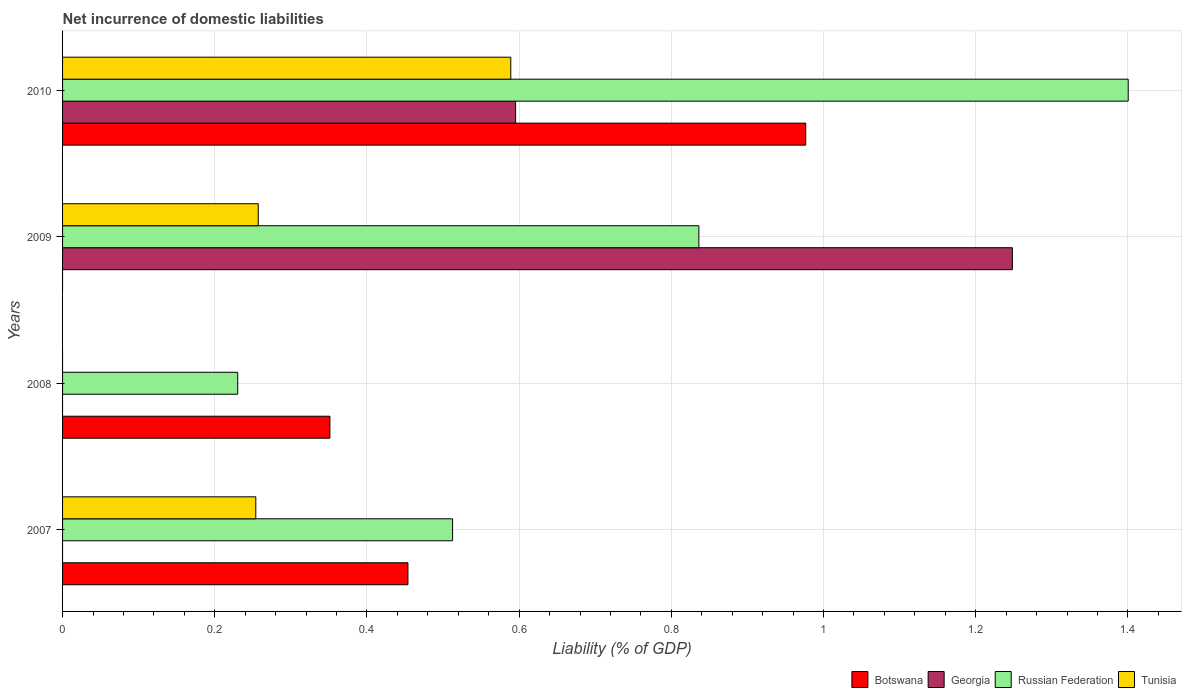How many different coloured bars are there?
Offer a very short reply. 4. How many bars are there on the 1st tick from the top?
Offer a very short reply. 4. How many bars are there on the 1st tick from the bottom?
Offer a very short reply. 3. What is the label of the 1st group of bars from the top?
Make the answer very short. 2010. In how many cases, is the number of bars for a given year not equal to the number of legend labels?
Ensure brevity in your answer.  3. What is the net incurrence of domestic liabilities in Botswana in 2007?
Give a very brief answer. 0.45. Across all years, what is the maximum net incurrence of domestic liabilities in Botswana?
Keep it short and to the point. 0.98. Across all years, what is the minimum net incurrence of domestic liabilities in Russian Federation?
Ensure brevity in your answer.  0.23. In which year was the net incurrence of domestic liabilities in Tunisia maximum?
Provide a short and direct response. 2010. What is the total net incurrence of domestic liabilities in Russian Federation in the graph?
Keep it short and to the point. 2.98. What is the difference between the net incurrence of domestic liabilities in Russian Federation in 2007 and that in 2009?
Give a very brief answer. -0.32. What is the difference between the net incurrence of domestic liabilities in Georgia in 2010 and the net incurrence of domestic liabilities in Botswana in 2009?
Your answer should be very brief. 0.6. What is the average net incurrence of domestic liabilities in Russian Federation per year?
Make the answer very short. 0.74. In the year 2010, what is the difference between the net incurrence of domestic liabilities in Russian Federation and net incurrence of domestic liabilities in Tunisia?
Your answer should be compact. 0.81. What is the ratio of the net incurrence of domestic liabilities in Botswana in 2007 to that in 2010?
Provide a short and direct response. 0.46. Is the difference between the net incurrence of domestic liabilities in Russian Federation in 2009 and 2010 greater than the difference between the net incurrence of domestic liabilities in Tunisia in 2009 and 2010?
Your answer should be very brief. No. What is the difference between the highest and the second highest net incurrence of domestic liabilities in Botswana?
Ensure brevity in your answer.  0.52. What is the difference between the highest and the lowest net incurrence of domestic liabilities in Russian Federation?
Provide a succinct answer. 1.17. In how many years, is the net incurrence of domestic liabilities in Russian Federation greater than the average net incurrence of domestic liabilities in Russian Federation taken over all years?
Offer a terse response. 2. Is the sum of the net incurrence of domestic liabilities in Russian Federation in 2009 and 2010 greater than the maximum net incurrence of domestic liabilities in Tunisia across all years?
Provide a succinct answer. Yes. Is it the case that in every year, the sum of the net incurrence of domestic liabilities in Georgia and net incurrence of domestic liabilities in Russian Federation is greater than the sum of net incurrence of domestic liabilities in Botswana and net incurrence of domestic liabilities in Tunisia?
Provide a short and direct response. No. How many bars are there?
Keep it short and to the point. 12. Are all the bars in the graph horizontal?
Offer a terse response. Yes. What is the difference between two consecutive major ticks on the X-axis?
Ensure brevity in your answer.  0.2. Does the graph contain any zero values?
Your answer should be compact. Yes. Does the graph contain grids?
Your response must be concise. Yes. Where does the legend appear in the graph?
Your answer should be compact. Bottom right. What is the title of the graph?
Your response must be concise. Net incurrence of domestic liabilities. Does "Belize" appear as one of the legend labels in the graph?
Give a very brief answer. No. What is the label or title of the X-axis?
Give a very brief answer. Liability (% of GDP). What is the label or title of the Y-axis?
Your answer should be compact. Years. What is the Liability (% of GDP) in Botswana in 2007?
Offer a very short reply. 0.45. What is the Liability (% of GDP) in Russian Federation in 2007?
Ensure brevity in your answer.  0.51. What is the Liability (% of GDP) in Tunisia in 2007?
Ensure brevity in your answer.  0.25. What is the Liability (% of GDP) of Botswana in 2008?
Offer a terse response. 0.35. What is the Liability (% of GDP) in Russian Federation in 2008?
Make the answer very short. 0.23. What is the Liability (% of GDP) of Tunisia in 2008?
Give a very brief answer. 0. What is the Liability (% of GDP) in Botswana in 2009?
Provide a short and direct response. 0. What is the Liability (% of GDP) in Georgia in 2009?
Offer a terse response. 1.25. What is the Liability (% of GDP) of Russian Federation in 2009?
Offer a terse response. 0.84. What is the Liability (% of GDP) of Tunisia in 2009?
Ensure brevity in your answer.  0.26. What is the Liability (% of GDP) in Botswana in 2010?
Give a very brief answer. 0.98. What is the Liability (% of GDP) of Georgia in 2010?
Your response must be concise. 0.6. What is the Liability (% of GDP) of Russian Federation in 2010?
Offer a terse response. 1.4. What is the Liability (% of GDP) of Tunisia in 2010?
Your answer should be very brief. 0.59. Across all years, what is the maximum Liability (% of GDP) in Botswana?
Your answer should be compact. 0.98. Across all years, what is the maximum Liability (% of GDP) of Georgia?
Your answer should be very brief. 1.25. Across all years, what is the maximum Liability (% of GDP) of Russian Federation?
Keep it short and to the point. 1.4. Across all years, what is the maximum Liability (% of GDP) in Tunisia?
Offer a terse response. 0.59. Across all years, what is the minimum Liability (% of GDP) in Georgia?
Give a very brief answer. 0. Across all years, what is the minimum Liability (% of GDP) of Russian Federation?
Offer a very short reply. 0.23. Across all years, what is the minimum Liability (% of GDP) of Tunisia?
Offer a very short reply. 0. What is the total Liability (% of GDP) in Botswana in the graph?
Provide a succinct answer. 1.78. What is the total Liability (% of GDP) in Georgia in the graph?
Give a very brief answer. 1.84. What is the total Liability (% of GDP) of Russian Federation in the graph?
Offer a terse response. 2.98. What is the total Liability (% of GDP) of Tunisia in the graph?
Make the answer very short. 1.1. What is the difference between the Liability (% of GDP) in Botswana in 2007 and that in 2008?
Ensure brevity in your answer.  0.1. What is the difference between the Liability (% of GDP) in Russian Federation in 2007 and that in 2008?
Provide a succinct answer. 0.28. What is the difference between the Liability (% of GDP) of Russian Federation in 2007 and that in 2009?
Provide a short and direct response. -0.32. What is the difference between the Liability (% of GDP) in Tunisia in 2007 and that in 2009?
Provide a short and direct response. -0. What is the difference between the Liability (% of GDP) in Botswana in 2007 and that in 2010?
Give a very brief answer. -0.52. What is the difference between the Liability (% of GDP) in Russian Federation in 2007 and that in 2010?
Keep it short and to the point. -0.89. What is the difference between the Liability (% of GDP) in Tunisia in 2007 and that in 2010?
Your answer should be compact. -0.34. What is the difference between the Liability (% of GDP) of Russian Federation in 2008 and that in 2009?
Offer a very short reply. -0.61. What is the difference between the Liability (% of GDP) in Botswana in 2008 and that in 2010?
Provide a short and direct response. -0.63. What is the difference between the Liability (% of GDP) of Russian Federation in 2008 and that in 2010?
Offer a very short reply. -1.17. What is the difference between the Liability (% of GDP) in Georgia in 2009 and that in 2010?
Make the answer very short. 0.65. What is the difference between the Liability (% of GDP) in Russian Federation in 2009 and that in 2010?
Your answer should be very brief. -0.56. What is the difference between the Liability (% of GDP) in Tunisia in 2009 and that in 2010?
Make the answer very short. -0.33. What is the difference between the Liability (% of GDP) in Botswana in 2007 and the Liability (% of GDP) in Russian Federation in 2008?
Your answer should be compact. 0.22. What is the difference between the Liability (% of GDP) of Botswana in 2007 and the Liability (% of GDP) of Georgia in 2009?
Provide a succinct answer. -0.79. What is the difference between the Liability (% of GDP) of Botswana in 2007 and the Liability (% of GDP) of Russian Federation in 2009?
Make the answer very short. -0.38. What is the difference between the Liability (% of GDP) of Botswana in 2007 and the Liability (% of GDP) of Tunisia in 2009?
Make the answer very short. 0.2. What is the difference between the Liability (% of GDP) in Russian Federation in 2007 and the Liability (% of GDP) in Tunisia in 2009?
Ensure brevity in your answer.  0.26. What is the difference between the Liability (% of GDP) in Botswana in 2007 and the Liability (% of GDP) in Georgia in 2010?
Your answer should be compact. -0.14. What is the difference between the Liability (% of GDP) in Botswana in 2007 and the Liability (% of GDP) in Russian Federation in 2010?
Your response must be concise. -0.95. What is the difference between the Liability (% of GDP) of Botswana in 2007 and the Liability (% of GDP) of Tunisia in 2010?
Offer a very short reply. -0.14. What is the difference between the Liability (% of GDP) in Russian Federation in 2007 and the Liability (% of GDP) in Tunisia in 2010?
Give a very brief answer. -0.08. What is the difference between the Liability (% of GDP) of Botswana in 2008 and the Liability (% of GDP) of Georgia in 2009?
Keep it short and to the point. -0.9. What is the difference between the Liability (% of GDP) in Botswana in 2008 and the Liability (% of GDP) in Russian Federation in 2009?
Your response must be concise. -0.48. What is the difference between the Liability (% of GDP) in Botswana in 2008 and the Liability (% of GDP) in Tunisia in 2009?
Keep it short and to the point. 0.09. What is the difference between the Liability (% of GDP) in Russian Federation in 2008 and the Liability (% of GDP) in Tunisia in 2009?
Make the answer very short. -0.03. What is the difference between the Liability (% of GDP) in Botswana in 2008 and the Liability (% of GDP) in Georgia in 2010?
Your answer should be compact. -0.24. What is the difference between the Liability (% of GDP) in Botswana in 2008 and the Liability (% of GDP) in Russian Federation in 2010?
Provide a short and direct response. -1.05. What is the difference between the Liability (% of GDP) of Botswana in 2008 and the Liability (% of GDP) of Tunisia in 2010?
Your answer should be compact. -0.24. What is the difference between the Liability (% of GDP) in Russian Federation in 2008 and the Liability (% of GDP) in Tunisia in 2010?
Offer a very short reply. -0.36. What is the difference between the Liability (% of GDP) of Georgia in 2009 and the Liability (% of GDP) of Russian Federation in 2010?
Keep it short and to the point. -0.15. What is the difference between the Liability (% of GDP) in Georgia in 2009 and the Liability (% of GDP) in Tunisia in 2010?
Provide a succinct answer. 0.66. What is the difference between the Liability (% of GDP) in Russian Federation in 2009 and the Liability (% of GDP) in Tunisia in 2010?
Keep it short and to the point. 0.25. What is the average Liability (% of GDP) in Botswana per year?
Ensure brevity in your answer.  0.45. What is the average Liability (% of GDP) in Georgia per year?
Provide a short and direct response. 0.46. What is the average Liability (% of GDP) of Russian Federation per year?
Your response must be concise. 0.74. What is the average Liability (% of GDP) in Tunisia per year?
Keep it short and to the point. 0.28. In the year 2007, what is the difference between the Liability (% of GDP) in Botswana and Liability (% of GDP) in Russian Federation?
Provide a succinct answer. -0.06. In the year 2007, what is the difference between the Liability (% of GDP) of Botswana and Liability (% of GDP) of Tunisia?
Make the answer very short. 0.2. In the year 2007, what is the difference between the Liability (% of GDP) in Russian Federation and Liability (% of GDP) in Tunisia?
Give a very brief answer. 0.26. In the year 2008, what is the difference between the Liability (% of GDP) of Botswana and Liability (% of GDP) of Russian Federation?
Offer a very short reply. 0.12. In the year 2009, what is the difference between the Liability (% of GDP) in Georgia and Liability (% of GDP) in Russian Federation?
Provide a short and direct response. 0.41. In the year 2009, what is the difference between the Liability (% of GDP) of Georgia and Liability (% of GDP) of Tunisia?
Provide a short and direct response. 0.99. In the year 2009, what is the difference between the Liability (% of GDP) of Russian Federation and Liability (% of GDP) of Tunisia?
Provide a succinct answer. 0.58. In the year 2010, what is the difference between the Liability (% of GDP) of Botswana and Liability (% of GDP) of Georgia?
Keep it short and to the point. 0.38. In the year 2010, what is the difference between the Liability (% of GDP) of Botswana and Liability (% of GDP) of Russian Federation?
Give a very brief answer. -0.42. In the year 2010, what is the difference between the Liability (% of GDP) in Botswana and Liability (% of GDP) in Tunisia?
Ensure brevity in your answer.  0.39. In the year 2010, what is the difference between the Liability (% of GDP) of Georgia and Liability (% of GDP) of Russian Federation?
Give a very brief answer. -0.81. In the year 2010, what is the difference between the Liability (% of GDP) of Georgia and Liability (% of GDP) of Tunisia?
Offer a terse response. 0.01. In the year 2010, what is the difference between the Liability (% of GDP) in Russian Federation and Liability (% of GDP) in Tunisia?
Your answer should be very brief. 0.81. What is the ratio of the Liability (% of GDP) of Botswana in 2007 to that in 2008?
Offer a terse response. 1.29. What is the ratio of the Liability (% of GDP) in Russian Federation in 2007 to that in 2008?
Make the answer very short. 2.23. What is the ratio of the Liability (% of GDP) of Russian Federation in 2007 to that in 2009?
Offer a terse response. 0.61. What is the ratio of the Liability (% of GDP) of Tunisia in 2007 to that in 2009?
Make the answer very short. 0.99. What is the ratio of the Liability (% of GDP) in Botswana in 2007 to that in 2010?
Give a very brief answer. 0.46. What is the ratio of the Liability (% of GDP) of Russian Federation in 2007 to that in 2010?
Provide a short and direct response. 0.37. What is the ratio of the Liability (% of GDP) in Tunisia in 2007 to that in 2010?
Provide a succinct answer. 0.43. What is the ratio of the Liability (% of GDP) of Russian Federation in 2008 to that in 2009?
Your answer should be compact. 0.28. What is the ratio of the Liability (% of GDP) of Botswana in 2008 to that in 2010?
Your response must be concise. 0.36. What is the ratio of the Liability (% of GDP) in Russian Federation in 2008 to that in 2010?
Your response must be concise. 0.16. What is the ratio of the Liability (% of GDP) in Georgia in 2009 to that in 2010?
Make the answer very short. 2.1. What is the ratio of the Liability (% of GDP) of Russian Federation in 2009 to that in 2010?
Make the answer very short. 0.6. What is the ratio of the Liability (% of GDP) in Tunisia in 2009 to that in 2010?
Make the answer very short. 0.44. What is the difference between the highest and the second highest Liability (% of GDP) in Botswana?
Keep it short and to the point. 0.52. What is the difference between the highest and the second highest Liability (% of GDP) in Russian Federation?
Make the answer very short. 0.56. What is the difference between the highest and the second highest Liability (% of GDP) in Tunisia?
Ensure brevity in your answer.  0.33. What is the difference between the highest and the lowest Liability (% of GDP) of Botswana?
Your answer should be very brief. 0.98. What is the difference between the highest and the lowest Liability (% of GDP) of Georgia?
Provide a succinct answer. 1.25. What is the difference between the highest and the lowest Liability (% of GDP) in Russian Federation?
Keep it short and to the point. 1.17. What is the difference between the highest and the lowest Liability (% of GDP) in Tunisia?
Your answer should be very brief. 0.59. 